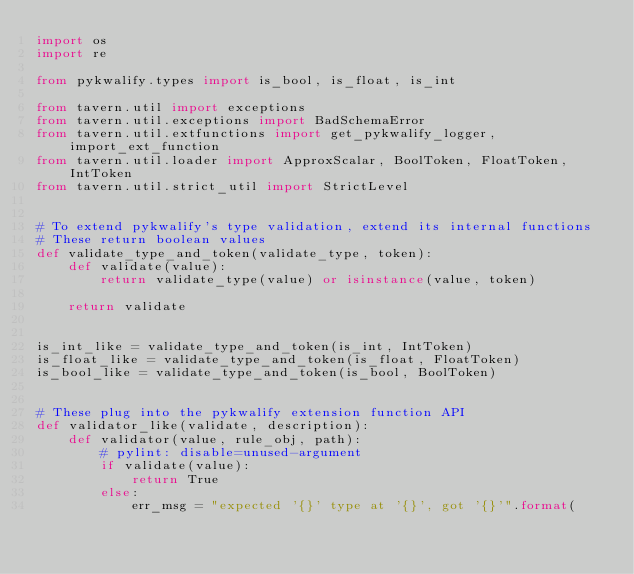<code> <loc_0><loc_0><loc_500><loc_500><_Python_>import os
import re

from pykwalify.types import is_bool, is_float, is_int

from tavern.util import exceptions
from tavern.util.exceptions import BadSchemaError
from tavern.util.extfunctions import get_pykwalify_logger, import_ext_function
from tavern.util.loader import ApproxScalar, BoolToken, FloatToken, IntToken
from tavern.util.strict_util import StrictLevel


# To extend pykwalify's type validation, extend its internal functions
# These return boolean values
def validate_type_and_token(validate_type, token):
    def validate(value):
        return validate_type(value) or isinstance(value, token)

    return validate


is_int_like = validate_type_and_token(is_int, IntToken)
is_float_like = validate_type_and_token(is_float, FloatToken)
is_bool_like = validate_type_and_token(is_bool, BoolToken)


# These plug into the pykwalify extension function API
def validator_like(validate, description):
    def validator(value, rule_obj, path):
        # pylint: disable=unused-argument
        if validate(value):
            return True
        else:
            err_msg = "expected '{}' type at '{}', got '{}'".format(</code> 